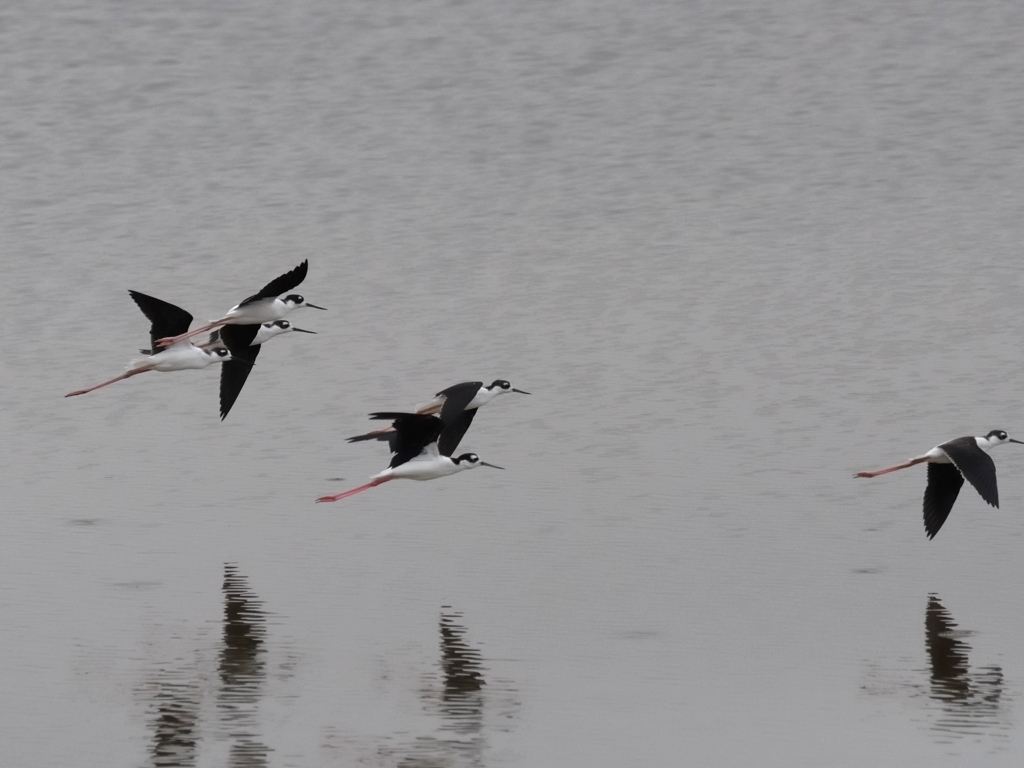Could you describe the motion captured in the image? What does it say about the birds' behavior? The image captures the birds smoothly gliding over the water with their wings fully outstretched, indicating they are either in the process of taking off or in steady flight. This behavior reflects agility and coordination, as well as their tendency to fly together in flocks for migration or movement between feeding sites. 